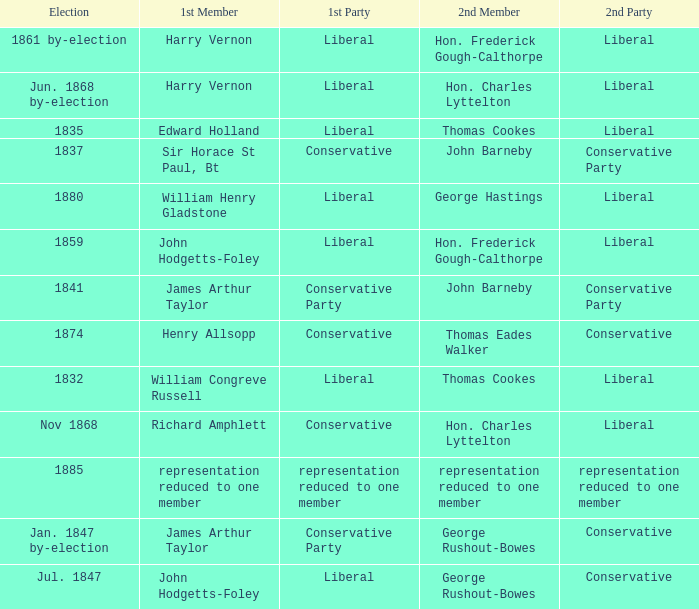What was the 2nd Party that had the 2nd Member John Barneby, when the 1st Party was Conservative? Conservative Party. 